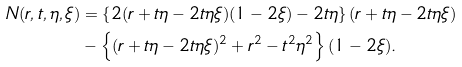<formula> <loc_0><loc_0><loc_500><loc_500>N ( r , t , \eta , \xi ) & = \left \{ 2 ( r + t \eta - 2 t \eta \xi ) ( 1 - 2 \xi ) - 2 t \eta \right \} ( r + t \eta - 2 t \eta \xi ) \\ & - \left \{ ( r + t \eta - 2 t \eta \xi ) ^ { 2 } + r ^ { 2 } - t ^ { 2 } \eta ^ { 2 } \right \} ( 1 - 2 \xi ) .</formula> 